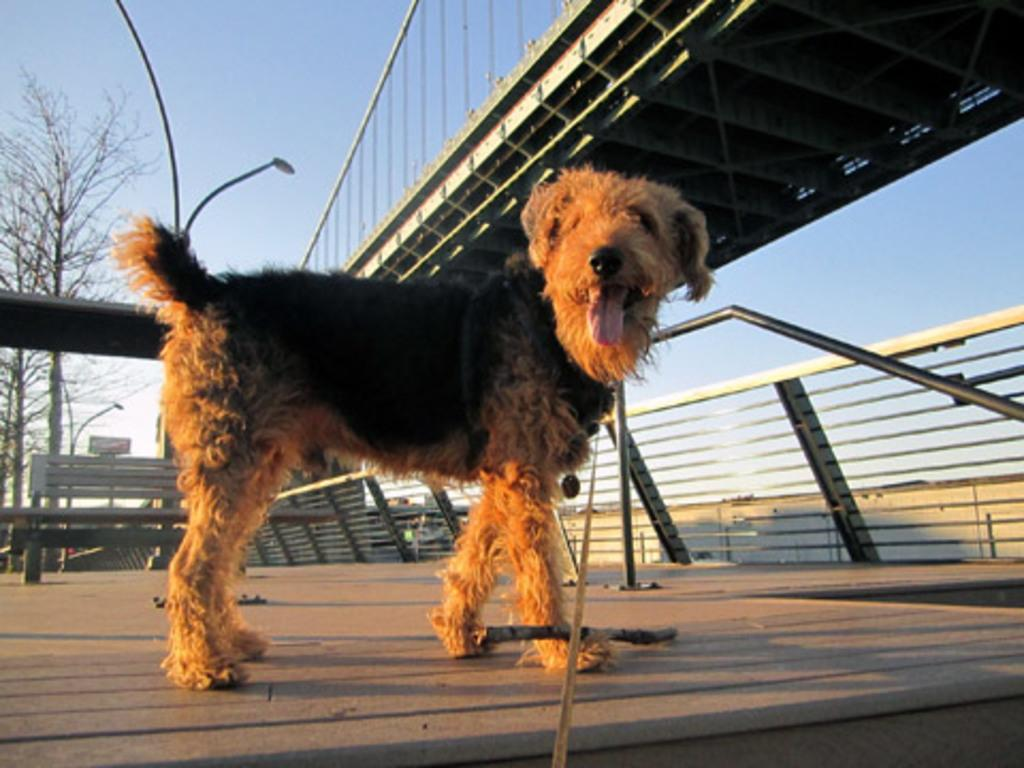What type of animal is in the image? There is a dog in the image. Can you describe the color of the dog? The dog is black and brown in color. What structures can be seen in the image? There is a bridge, a fence, and light poles in the image. What type of natural elements are present in the image? There are trees in the image. What part of the natural environment is visible in the image? The sky is visible in the image. What type of comparison can be made between the dog and a cub in the image? There is no cub present in the image, so no comparison can be made between the dog and a cub. What type of lunch is being served in the image? There is no reference to lunch in the image, so it cannot be determined what type of lunch is being served. 